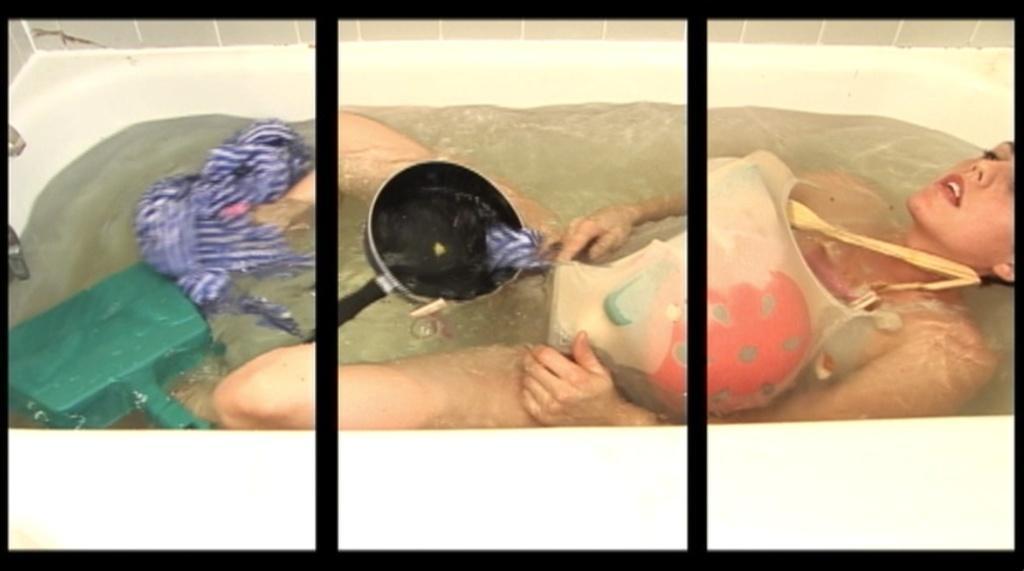In one or two sentences, can you explain what this image depicts? In this image we can see a person in the bath tub, in the bathtub we can see a cloth, pan and an object, in the background we can see the wall. 